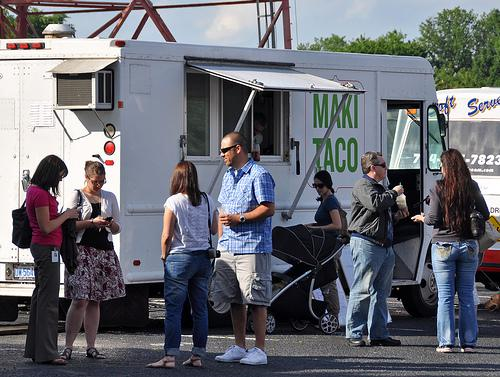Question: who is ordering right now?
Choices:
A. Man in black.
B. Woman in red.
C. A woman with a baby.
D. Boy in blue.
Answer with the letter. Answer: C Question: why are they ordering tacos?
Choices:
A. Lunch time.
B. Dinner time.
C. They are hungry.
D. They like tacos.
Answer with the letter. Answer: C Question: what does this truck sell?
Choices:
A. Ice cream.
B. Burgers.
C. Tacos.
D. Hot dogs.
Answer with the letter. Answer: C Question: what color is the truck?
Choices:
A. Red.
B. Blue.
C. White.
D. Green.
Answer with the letter. Answer: C Question: where are they located?
Choices:
A. Parking lot.
B. Outside on blacktop.
C. Recreational event.
D. Park.
Answer with the letter. Answer: B Question: when was the photo taken?
Choices:
A. Morning.
B. Daylight hours.
C. Noon.
D. Evening.
Answer with the letter. Answer: B 